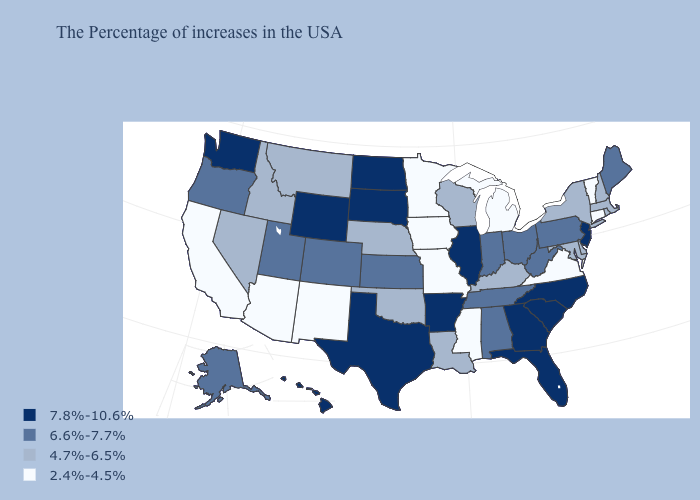Which states hav the highest value in the West?
Concise answer only. Wyoming, Washington, Hawaii. What is the lowest value in the USA?
Be succinct. 2.4%-4.5%. Does South Dakota have the highest value in the USA?
Write a very short answer. Yes. Name the states that have a value in the range 2.4%-4.5%?
Concise answer only. Vermont, Connecticut, Virginia, Michigan, Mississippi, Missouri, Minnesota, Iowa, New Mexico, Arizona, California. Does Georgia have the highest value in the USA?
Be succinct. Yes. What is the highest value in the Northeast ?
Be succinct. 7.8%-10.6%. Does Nevada have a higher value than Mississippi?
Write a very short answer. Yes. Name the states that have a value in the range 7.8%-10.6%?
Keep it brief. New Jersey, North Carolina, South Carolina, Florida, Georgia, Illinois, Arkansas, Texas, South Dakota, North Dakota, Wyoming, Washington, Hawaii. How many symbols are there in the legend?
Answer briefly. 4. Which states have the highest value in the USA?
Write a very short answer. New Jersey, North Carolina, South Carolina, Florida, Georgia, Illinois, Arkansas, Texas, South Dakota, North Dakota, Wyoming, Washington, Hawaii. Name the states that have a value in the range 4.7%-6.5%?
Quick response, please. Massachusetts, Rhode Island, New Hampshire, New York, Delaware, Maryland, Kentucky, Wisconsin, Louisiana, Nebraska, Oklahoma, Montana, Idaho, Nevada. Name the states that have a value in the range 7.8%-10.6%?
Give a very brief answer. New Jersey, North Carolina, South Carolina, Florida, Georgia, Illinois, Arkansas, Texas, South Dakota, North Dakota, Wyoming, Washington, Hawaii. Among the states that border Washington , does Oregon have the highest value?
Quick response, please. Yes. Name the states that have a value in the range 7.8%-10.6%?
Concise answer only. New Jersey, North Carolina, South Carolina, Florida, Georgia, Illinois, Arkansas, Texas, South Dakota, North Dakota, Wyoming, Washington, Hawaii. What is the value of Connecticut?
Give a very brief answer. 2.4%-4.5%. 